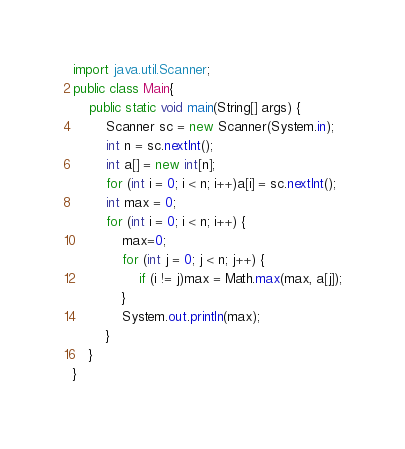Convert code to text. <code><loc_0><loc_0><loc_500><loc_500><_Java_>import java.util.Scanner;
public class Main{
	public static void main(String[] args) {
		Scanner sc = new Scanner(System.in);
		int n = sc.nextInt();
		int a[] = new int[n];
		for (int i = 0; i < n; i++)a[i] = sc.nextInt();
		int max = 0;
		for (int i = 0; i < n; i++) {
			max=0;
			for (int j = 0; j < n; j++) {
				if (i != j)max = Math.max(max, a[j]);
			}
			System.out.println(max);
		}
	}
}
</code> 